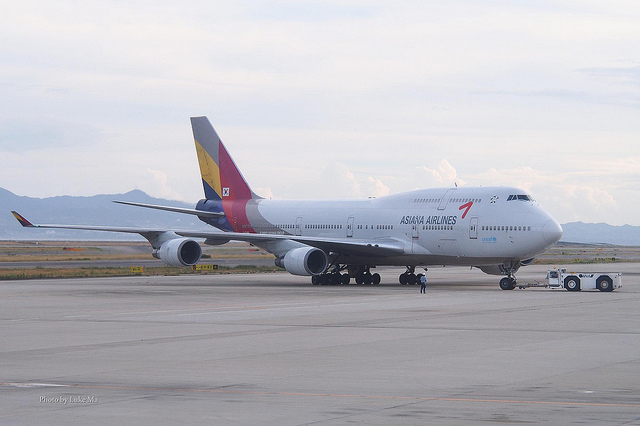Identify the text displayed in this image. ASIANA AIRLINES 7 